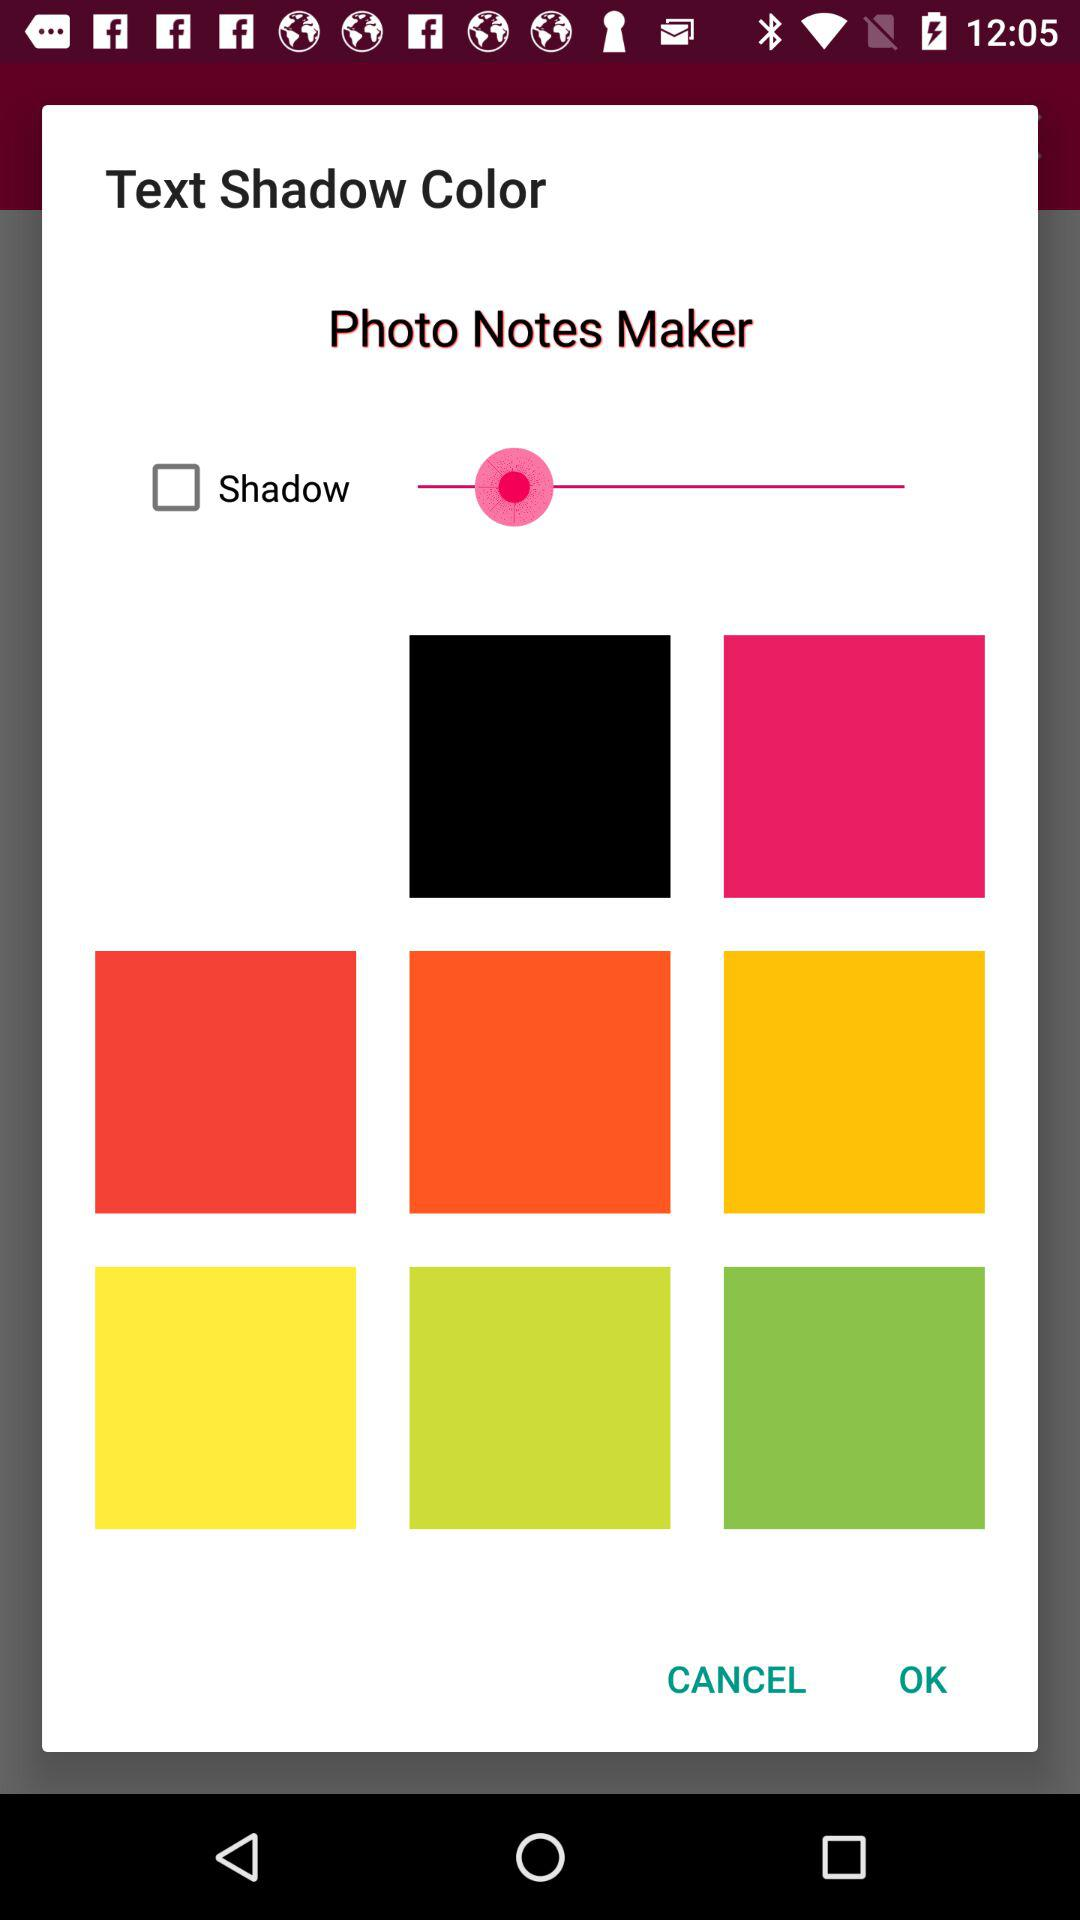What is the status of Shadow? The status is off. 